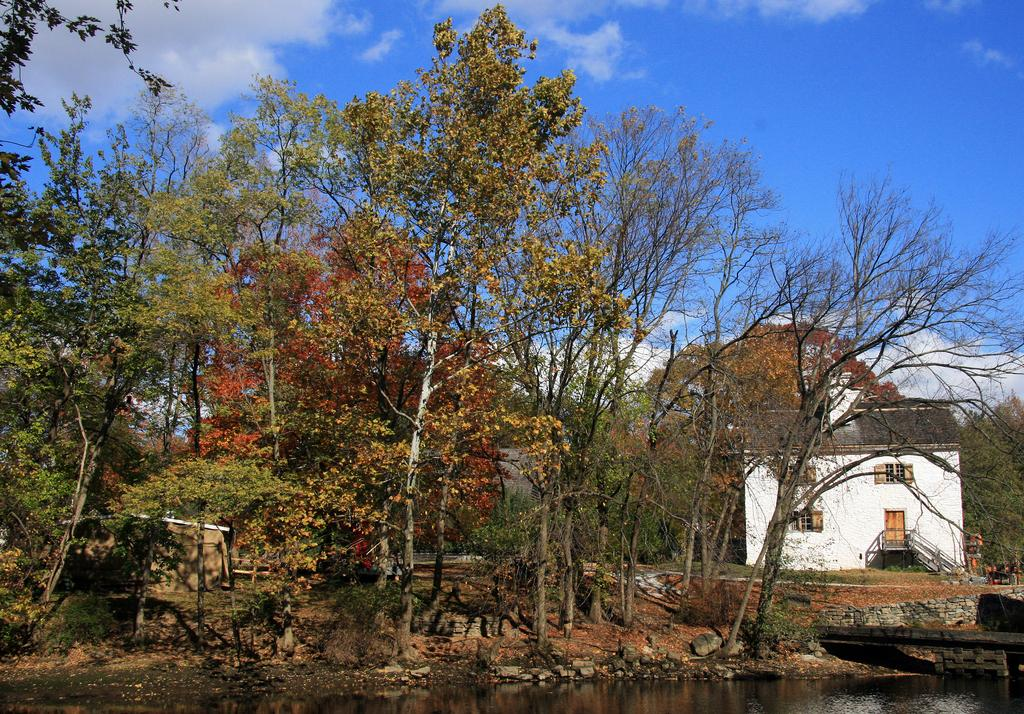What is one of the main elements in the image? There is water in the image. What other natural elements can be seen in the image? There are stones, trees, and the sky visible in the image. Can you describe the structure in the image? There is a shed with windows in the image. What else is present in the image besides the natural elements and the shed? There are objects in the image. What is the condition of the sky in the image? The sky is visible in the background of the image, and there are clouds in the sky. What type of wax can be seen dripping from the trees in the image? There is no wax present in the image; the trees are not depicted as dripping wax. How many flowers are visible on the stones in the image? There are no flowers visible on the stones in the image. 